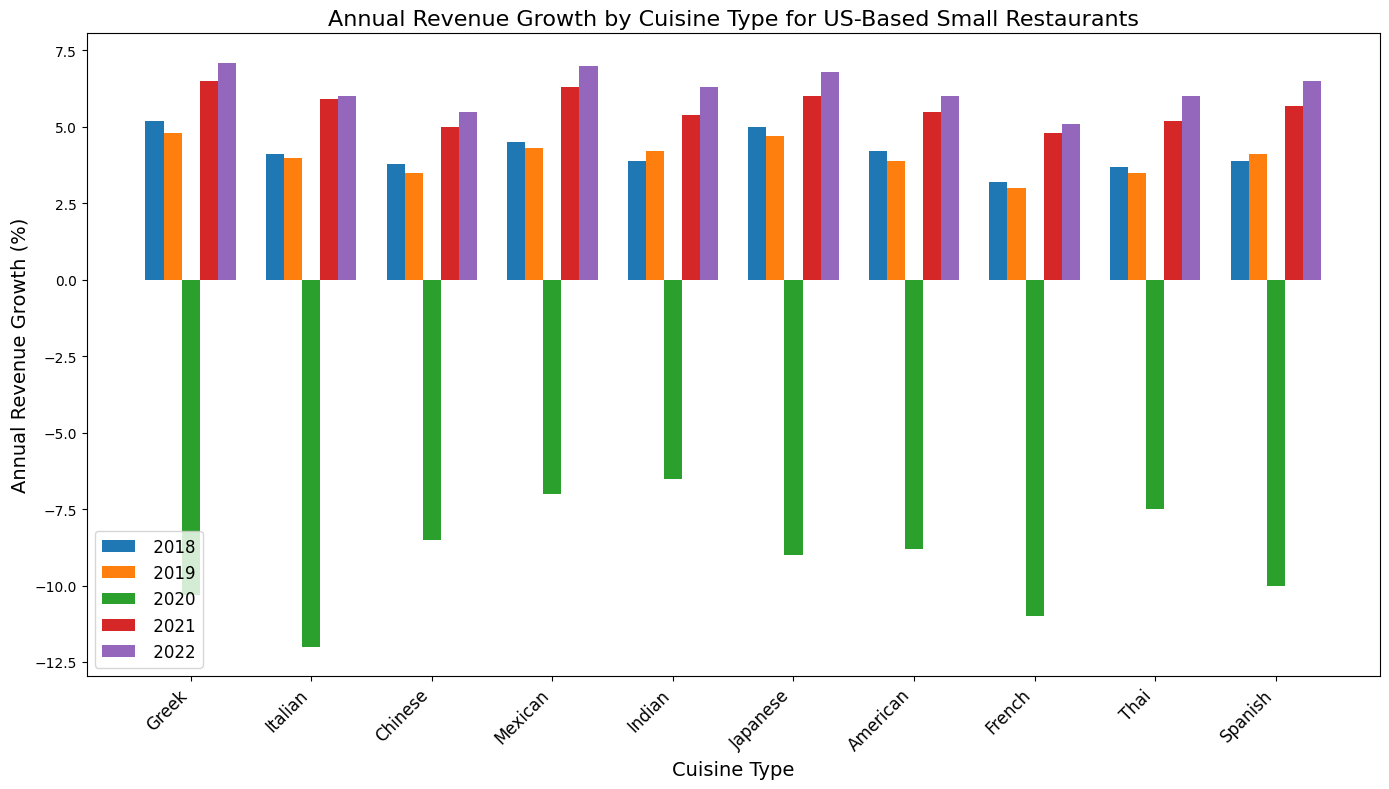Which cuisine type had the highest revenue growth in 2022? Look for the tallest bar in the 2022 section and find the corresponding cuisine type.
Answer: Greek Which cuisine type saw the largest decline in revenue in 2020? Find the bar with the lowest (most negative) value in the 2020 section and identify the cuisine type.
Answer: Italian What is the average revenue growth for Mexican cuisine from 2018 to 2022? Sum the revenue growth values for Mexican cuisine from 2018 to 2022, then divide by the number of years (5). (4.5 + 4.3 + -7.0 + 6.3 + 7.0) / 5 = 3.42
Answer: 3.42 Compare the revenue growth of Greek and Italian cuisines in 2021. Which one is greater? Look at the bars for Greek and Italian cuisines in the 2021 section and compare their heights. Greek cuisine has higher revenue growth in 2021.
Answer: Greek Which two cuisine types had the smallest difference in revenue growth in 2019? Check the 2019 section and identify the pairs with close bar heights, then calculate differences. Greek and Japanese cuisines both have 0.1 difference in growth.
Answer: Greek and Japanese What's the overall trend in revenue growth for Japanese cuisine from 2018 to 2022? Observe the bars for Japanese cuisine across the years and describe the trend from start to end. Growth decreases initially, drops in 2020, then increases steadily.
Answer: Decrease, then steady increase What was the combined revenue growth of Indian and Spanish cuisines in 2022? Add the revenue growth values for Indian and Spanish cuisines from 2022. (6.3 + 6.5) = 12.8
Answer: 12.8 Compare the revenue growth of American and French cuisines in 2020. What can you infer? Look at the 2020 section for American and French cuisines and compare the bars. Both are negative, but the drop for French cuisine is larger.
Answer: Both negative, French worse Does Thai cuisine have a consistent revenue growth pattern every year from 2018 to 2022? Examine the bars for Thai cuisine and see if they follow a consistent up or down pattern. Thai growth fluctuates but trends upward after 2020.
Answer: Not consistent but trends upward after 2020 Which cuisine type had the second highest revenue growth in 2018? Identify the second tallest bar in the 2018 section and find the corresponding cuisine. Japanese cuisine had the second highest growth.
Answer: Japanese 